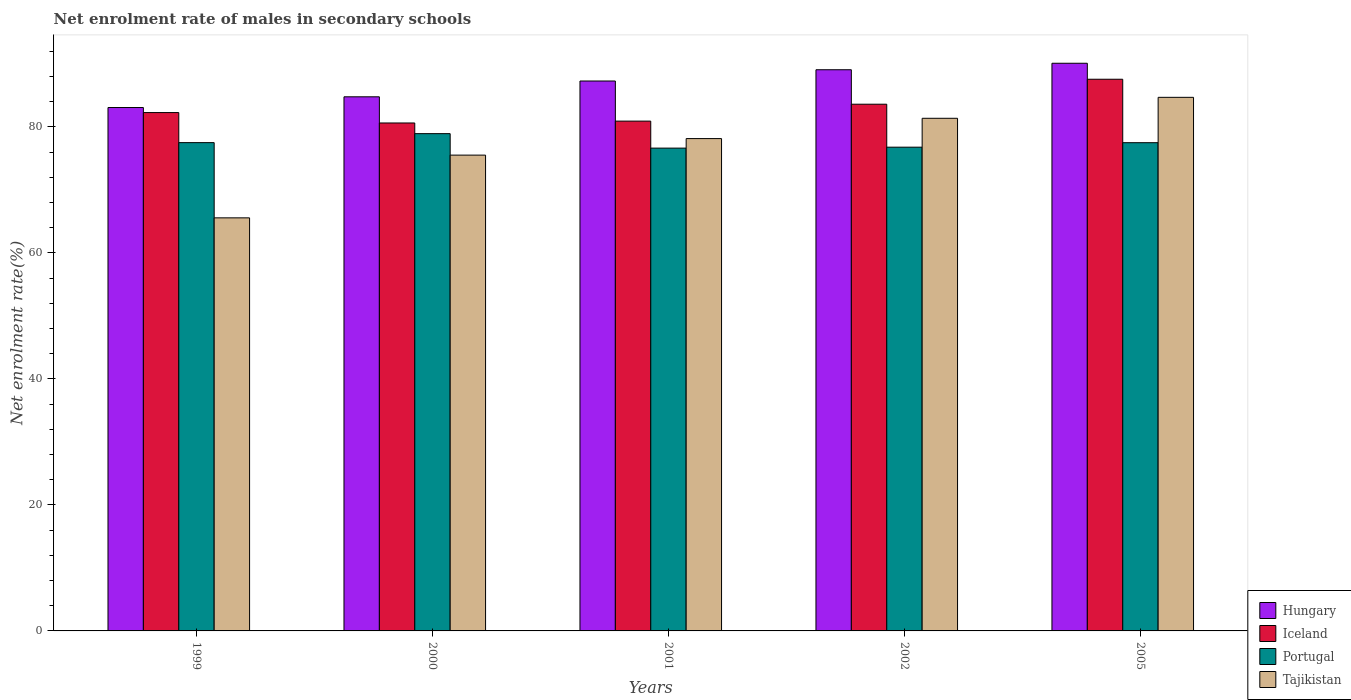How many different coloured bars are there?
Your answer should be compact. 4. How many bars are there on the 3rd tick from the left?
Your response must be concise. 4. What is the label of the 3rd group of bars from the left?
Keep it short and to the point. 2001. What is the net enrolment rate of males in secondary schools in Tajikistan in 2002?
Your answer should be compact. 81.36. Across all years, what is the maximum net enrolment rate of males in secondary schools in Iceland?
Give a very brief answer. 87.55. Across all years, what is the minimum net enrolment rate of males in secondary schools in Iceland?
Ensure brevity in your answer.  80.61. In which year was the net enrolment rate of males in secondary schools in Portugal maximum?
Give a very brief answer. 2000. In which year was the net enrolment rate of males in secondary schools in Iceland minimum?
Keep it short and to the point. 2000. What is the total net enrolment rate of males in secondary schools in Iceland in the graph?
Your response must be concise. 414.92. What is the difference between the net enrolment rate of males in secondary schools in Portugal in 2000 and that in 2002?
Ensure brevity in your answer.  2.15. What is the difference between the net enrolment rate of males in secondary schools in Tajikistan in 2000 and the net enrolment rate of males in secondary schools in Hungary in 1999?
Keep it short and to the point. -7.55. What is the average net enrolment rate of males in secondary schools in Tajikistan per year?
Your answer should be very brief. 77.05. In the year 2005, what is the difference between the net enrolment rate of males in secondary schools in Hungary and net enrolment rate of males in secondary schools in Portugal?
Your answer should be compact. 12.61. What is the ratio of the net enrolment rate of males in secondary schools in Tajikistan in 1999 to that in 2000?
Give a very brief answer. 0.87. Is the difference between the net enrolment rate of males in secondary schools in Hungary in 1999 and 2002 greater than the difference between the net enrolment rate of males in secondary schools in Portugal in 1999 and 2002?
Make the answer very short. No. What is the difference between the highest and the second highest net enrolment rate of males in secondary schools in Hungary?
Offer a very short reply. 1.03. What is the difference between the highest and the lowest net enrolment rate of males in secondary schools in Tajikistan?
Ensure brevity in your answer.  19.13. In how many years, is the net enrolment rate of males in secondary schools in Hungary greater than the average net enrolment rate of males in secondary schools in Hungary taken over all years?
Your response must be concise. 3. What does the 1st bar from the left in 2005 represents?
Make the answer very short. Hungary. How many bars are there?
Give a very brief answer. 20. What is the difference between two consecutive major ticks on the Y-axis?
Provide a short and direct response. 20. Are the values on the major ticks of Y-axis written in scientific E-notation?
Your answer should be very brief. No. Does the graph contain any zero values?
Your answer should be compact. No. Does the graph contain grids?
Ensure brevity in your answer.  No. What is the title of the graph?
Your answer should be compact. Net enrolment rate of males in secondary schools. Does "Mali" appear as one of the legend labels in the graph?
Provide a short and direct response. No. What is the label or title of the Y-axis?
Ensure brevity in your answer.  Net enrolment rate(%). What is the Net enrolment rate(%) of Hungary in 1999?
Your answer should be very brief. 83.06. What is the Net enrolment rate(%) of Iceland in 1999?
Give a very brief answer. 82.26. What is the Net enrolment rate(%) of Portugal in 1999?
Offer a very short reply. 77.49. What is the Net enrolment rate(%) in Tajikistan in 1999?
Give a very brief answer. 65.55. What is the Net enrolment rate(%) of Hungary in 2000?
Your answer should be compact. 84.76. What is the Net enrolment rate(%) in Iceland in 2000?
Ensure brevity in your answer.  80.61. What is the Net enrolment rate(%) of Portugal in 2000?
Give a very brief answer. 78.92. What is the Net enrolment rate(%) of Tajikistan in 2000?
Your answer should be very brief. 75.51. What is the Net enrolment rate(%) of Hungary in 2001?
Make the answer very short. 87.27. What is the Net enrolment rate(%) of Iceland in 2001?
Your response must be concise. 80.91. What is the Net enrolment rate(%) of Portugal in 2001?
Your answer should be very brief. 76.62. What is the Net enrolment rate(%) of Tajikistan in 2001?
Provide a succinct answer. 78.13. What is the Net enrolment rate(%) of Hungary in 2002?
Offer a very short reply. 89.06. What is the Net enrolment rate(%) in Iceland in 2002?
Make the answer very short. 83.59. What is the Net enrolment rate(%) of Portugal in 2002?
Give a very brief answer. 76.77. What is the Net enrolment rate(%) of Tajikistan in 2002?
Offer a very short reply. 81.36. What is the Net enrolment rate(%) in Hungary in 2005?
Offer a terse response. 90.09. What is the Net enrolment rate(%) in Iceland in 2005?
Your response must be concise. 87.55. What is the Net enrolment rate(%) in Portugal in 2005?
Your answer should be compact. 77.48. What is the Net enrolment rate(%) in Tajikistan in 2005?
Your answer should be very brief. 84.68. Across all years, what is the maximum Net enrolment rate(%) of Hungary?
Your answer should be very brief. 90.09. Across all years, what is the maximum Net enrolment rate(%) of Iceland?
Provide a succinct answer. 87.55. Across all years, what is the maximum Net enrolment rate(%) in Portugal?
Keep it short and to the point. 78.92. Across all years, what is the maximum Net enrolment rate(%) in Tajikistan?
Provide a short and direct response. 84.68. Across all years, what is the minimum Net enrolment rate(%) of Hungary?
Offer a terse response. 83.06. Across all years, what is the minimum Net enrolment rate(%) of Iceland?
Make the answer very short. 80.61. Across all years, what is the minimum Net enrolment rate(%) in Portugal?
Your answer should be compact. 76.62. Across all years, what is the minimum Net enrolment rate(%) of Tajikistan?
Your answer should be very brief. 65.55. What is the total Net enrolment rate(%) of Hungary in the graph?
Provide a short and direct response. 434.25. What is the total Net enrolment rate(%) of Iceland in the graph?
Give a very brief answer. 414.92. What is the total Net enrolment rate(%) of Portugal in the graph?
Your answer should be very brief. 387.29. What is the total Net enrolment rate(%) in Tajikistan in the graph?
Your answer should be very brief. 385.23. What is the difference between the Net enrolment rate(%) in Hungary in 1999 and that in 2000?
Provide a succinct answer. -1.7. What is the difference between the Net enrolment rate(%) of Iceland in 1999 and that in 2000?
Keep it short and to the point. 1.65. What is the difference between the Net enrolment rate(%) of Portugal in 1999 and that in 2000?
Offer a very short reply. -1.43. What is the difference between the Net enrolment rate(%) of Tajikistan in 1999 and that in 2000?
Your answer should be compact. -9.96. What is the difference between the Net enrolment rate(%) in Hungary in 1999 and that in 2001?
Make the answer very short. -4.21. What is the difference between the Net enrolment rate(%) in Iceland in 1999 and that in 2001?
Your response must be concise. 1.36. What is the difference between the Net enrolment rate(%) of Portugal in 1999 and that in 2001?
Your answer should be compact. 0.87. What is the difference between the Net enrolment rate(%) in Tajikistan in 1999 and that in 2001?
Your response must be concise. -12.58. What is the difference between the Net enrolment rate(%) in Hungary in 1999 and that in 2002?
Keep it short and to the point. -6. What is the difference between the Net enrolment rate(%) of Iceland in 1999 and that in 2002?
Your answer should be very brief. -1.33. What is the difference between the Net enrolment rate(%) in Portugal in 1999 and that in 2002?
Your answer should be compact. 0.72. What is the difference between the Net enrolment rate(%) of Tajikistan in 1999 and that in 2002?
Keep it short and to the point. -15.8. What is the difference between the Net enrolment rate(%) in Hungary in 1999 and that in 2005?
Provide a short and direct response. -7.02. What is the difference between the Net enrolment rate(%) of Iceland in 1999 and that in 2005?
Provide a succinct answer. -5.29. What is the difference between the Net enrolment rate(%) in Portugal in 1999 and that in 2005?
Ensure brevity in your answer.  0.01. What is the difference between the Net enrolment rate(%) of Tajikistan in 1999 and that in 2005?
Keep it short and to the point. -19.13. What is the difference between the Net enrolment rate(%) of Hungary in 2000 and that in 2001?
Provide a short and direct response. -2.51. What is the difference between the Net enrolment rate(%) in Iceland in 2000 and that in 2001?
Your response must be concise. -0.29. What is the difference between the Net enrolment rate(%) of Portugal in 2000 and that in 2001?
Ensure brevity in your answer.  2.3. What is the difference between the Net enrolment rate(%) in Tajikistan in 2000 and that in 2001?
Provide a succinct answer. -2.63. What is the difference between the Net enrolment rate(%) in Hungary in 2000 and that in 2002?
Keep it short and to the point. -4.3. What is the difference between the Net enrolment rate(%) of Iceland in 2000 and that in 2002?
Your response must be concise. -2.98. What is the difference between the Net enrolment rate(%) in Portugal in 2000 and that in 2002?
Provide a succinct answer. 2.15. What is the difference between the Net enrolment rate(%) in Tajikistan in 2000 and that in 2002?
Your answer should be compact. -5.85. What is the difference between the Net enrolment rate(%) in Hungary in 2000 and that in 2005?
Provide a succinct answer. -5.32. What is the difference between the Net enrolment rate(%) of Iceland in 2000 and that in 2005?
Offer a terse response. -6.94. What is the difference between the Net enrolment rate(%) of Portugal in 2000 and that in 2005?
Keep it short and to the point. 1.44. What is the difference between the Net enrolment rate(%) in Tajikistan in 2000 and that in 2005?
Make the answer very short. -9.17. What is the difference between the Net enrolment rate(%) in Hungary in 2001 and that in 2002?
Provide a succinct answer. -1.79. What is the difference between the Net enrolment rate(%) of Iceland in 2001 and that in 2002?
Provide a succinct answer. -2.68. What is the difference between the Net enrolment rate(%) in Portugal in 2001 and that in 2002?
Ensure brevity in your answer.  -0.15. What is the difference between the Net enrolment rate(%) of Tajikistan in 2001 and that in 2002?
Give a very brief answer. -3.22. What is the difference between the Net enrolment rate(%) in Hungary in 2001 and that in 2005?
Keep it short and to the point. -2.82. What is the difference between the Net enrolment rate(%) of Iceland in 2001 and that in 2005?
Your answer should be very brief. -6.65. What is the difference between the Net enrolment rate(%) of Portugal in 2001 and that in 2005?
Provide a succinct answer. -0.86. What is the difference between the Net enrolment rate(%) of Tajikistan in 2001 and that in 2005?
Ensure brevity in your answer.  -6.55. What is the difference between the Net enrolment rate(%) in Hungary in 2002 and that in 2005?
Your answer should be compact. -1.03. What is the difference between the Net enrolment rate(%) of Iceland in 2002 and that in 2005?
Offer a terse response. -3.96. What is the difference between the Net enrolment rate(%) of Portugal in 2002 and that in 2005?
Provide a short and direct response. -0.71. What is the difference between the Net enrolment rate(%) of Tajikistan in 2002 and that in 2005?
Your answer should be very brief. -3.32. What is the difference between the Net enrolment rate(%) of Hungary in 1999 and the Net enrolment rate(%) of Iceland in 2000?
Provide a succinct answer. 2.45. What is the difference between the Net enrolment rate(%) in Hungary in 1999 and the Net enrolment rate(%) in Portugal in 2000?
Your answer should be compact. 4.15. What is the difference between the Net enrolment rate(%) of Hungary in 1999 and the Net enrolment rate(%) of Tajikistan in 2000?
Offer a terse response. 7.55. What is the difference between the Net enrolment rate(%) in Iceland in 1999 and the Net enrolment rate(%) in Portugal in 2000?
Ensure brevity in your answer.  3.34. What is the difference between the Net enrolment rate(%) in Iceland in 1999 and the Net enrolment rate(%) in Tajikistan in 2000?
Provide a succinct answer. 6.75. What is the difference between the Net enrolment rate(%) in Portugal in 1999 and the Net enrolment rate(%) in Tajikistan in 2000?
Give a very brief answer. 1.98. What is the difference between the Net enrolment rate(%) in Hungary in 1999 and the Net enrolment rate(%) in Iceland in 2001?
Give a very brief answer. 2.16. What is the difference between the Net enrolment rate(%) of Hungary in 1999 and the Net enrolment rate(%) of Portugal in 2001?
Offer a very short reply. 6.44. What is the difference between the Net enrolment rate(%) in Hungary in 1999 and the Net enrolment rate(%) in Tajikistan in 2001?
Your response must be concise. 4.93. What is the difference between the Net enrolment rate(%) in Iceland in 1999 and the Net enrolment rate(%) in Portugal in 2001?
Give a very brief answer. 5.64. What is the difference between the Net enrolment rate(%) in Iceland in 1999 and the Net enrolment rate(%) in Tajikistan in 2001?
Make the answer very short. 4.13. What is the difference between the Net enrolment rate(%) in Portugal in 1999 and the Net enrolment rate(%) in Tajikistan in 2001?
Make the answer very short. -0.64. What is the difference between the Net enrolment rate(%) in Hungary in 1999 and the Net enrolment rate(%) in Iceland in 2002?
Your answer should be compact. -0.53. What is the difference between the Net enrolment rate(%) in Hungary in 1999 and the Net enrolment rate(%) in Portugal in 2002?
Offer a very short reply. 6.29. What is the difference between the Net enrolment rate(%) in Hungary in 1999 and the Net enrolment rate(%) in Tajikistan in 2002?
Provide a succinct answer. 1.71. What is the difference between the Net enrolment rate(%) of Iceland in 1999 and the Net enrolment rate(%) of Portugal in 2002?
Offer a terse response. 5.49. What is the difference between the Net enrolment rate(%) in Iceland in 1999 and the Net enrolment rate(%) in Tajikistan in 2002?
Your response must be concise. 0.91. What is the difference between the Net enrolment rate(%) of Portugal in 1999 and the Net enrolment rate(%) of Tajikistan in 2002?
Your answer should be compact. -3.86. What is the difference between the Net enrolment rate(%) in Hungary in 1999 and the Net enrolment rate(%) in Iceland in 2005?
Provide a succinct answer. -4.49. What is the difference between the Net enrolment rate(%) in Hungary in 1999 and the Net enrolment rate(%) in Portugal in 2005?
Give a very brief answer. 5.58. What is the difference between the Net enrolment rate(%) in Hungary in 1999 and the Net enrolment rate(%) in Tajikistan in 2005?
Provide a succinct answer. -1.62. What is the difference between the Net enrolment rate(%) in Iceland in 1999 and the Net enrolment rate(%) in Portugal in 2005?
Make the answer very short. 4.78. What is the difference between the Net enrolment rate(%) of Iceland in 1999 and the Net enrolment rate(%) of Tajikistan in 2005?
Your answer should be very brief. -2.42. What is the difference between the Net enrolment rate(%) of Portugal in 1999 and the Net enrolment rate(%) of Tajikistan in 2005?
Offer a terse response. -7.19. What is the difference between the Net enrolment rate(%) in Hungary in 2000 and the Net enrolment rate(%) in Iceland in 2001?
Provide a short and direct response. 3.86. What is the difference between the Net enrolment rate(%) of Hungary in 2000 and the Net enrolment rate(%) of Portugal in 2001?
Your answer should be very brief. 8.14. What is the difference between the Net enrolment rate(%) of Hungary in 2000 and the Net enrolment rate(%) of Tajikistan in 2001?
Give a very brief answer. 6.63. What is the difference between the Net enrolment rate(%) of Iceland in 2000 and the Net enrolment rate(%) of Portugal in 2001?
Your answer should be very brief. 3.99. What is the difference between the Net enrolment rate(%) in Iceland in 2000 and the Net enrolment rate(%) in Tajikistan in 2001?
Your response must be concise. 2.48. What is the difference between the Net enrolment rate(%) in Portugal in 2000 and the Net enrolment rate(%) in Tajikistan in 2001?
Make the answer very short. 0.78. What is the difference between the Net enrolment rate(%) of Hungary in 2000 and the Net enrolment rate(%) of Iceland in 2002?
Offer a terse response. 1.17. What is the difference between the Net enrolment rate(%) in Hungary in 2000 and the Net enrolment rate(%) in Portugal in 2002?
Provide a short and direct response. 7.99. What is the difference between the Net enrolment rate(%) in Hungary in 2000 and the Net enrolment rate(%) in Tajikistan in 2002?
Keep it short and to the point. 3.41. What is the difference between the Net enrolment rate(%) in Iceland in 2000 and the Net enrolment rate(%) in Portugal in 2002?
Keep it short and to the point. 3.84. What is the difference between the Net enrolment rate(%) in Iceland in 2000 and the Net enrolment rate(%) in Tajikistan in 2002?
Offer a terse response. -0.74. What is the difference between the Net enrolment rate(%) in Portugal in 2000 and the Net enrolment rate(%) in Tajikistan in 2002?
Make the answer very short. -2.44. What is the difference between the Net enrolment rate(%) in Hungary in 2000 and the Net enrolment rate(%) in Iceland in 2005?
Offer a very short reply. -2.79. What is the difference between the Net enrolment rate(%) of Hungary in 2000 and the Net enrolment rate(%) of Portugal in 2005?
Provide a short and direct response. 7.28. What is the difference between the Net enrolment rate(%) in Hungary in 2000 and the Net enrolment rate(%) in Tajikistan in 2005?
Provide a short and direct response. 0.08. What is the difference between the Net enrolment rate(%) of Iceland in 2000 and the Net enrolment rate(%) of Portugal in 2005?
Your answer should be compact. 3.13. What is the difference between the Net enrolment rate(%) in Iceland in 2000 and the Net enrolment rate(%) in Tajikistan in 2005?
Your answer should be compact. -4.07. What is the difference between the Net enrolment rate(%) in Portugal in 2000 and the Net enrolment rate(%) in Tajikistan in 2005?
Offer a terse response. -5.76. What is the difference between the Net enrolment rate(%) in Hungary in 2001 and the Net enrolment rate(%) in Iceland in 2002?
Your answer should be compact. 3.68. What is the difference between the Net enrolment rate(%) of Hungary in 2001 and the Net enrolment rate(%) of Portugal in 2002?
Give a very brief answer. 10.5. What is the difference between the Net enrolment rate(%) of Hungary in 2001 and the Net enrolment rate(%) of Tajikistan in 2002?
Your answer should be compact. 5.92. What is the difference between the Net enrolment rate(%) of Iceland in 2001 and the Net enrolment rate(%) of Portugal in 2002?
Your answer should be compact. 4.13. What is the difference between the Net enrolment rate(%) in Iceland in 2001 and the Net enrolment rate(%) in Tajikistan in 2002?
Offer a terse response. -0.45. What is the difference between the Net enrolment rate(%) in Portugal in 2001 and the Net enrolment rate(%) in Tajikistan in 2002?
Your response must be concise. -4.73. What is the difference between the Net enrolment rate(%) in Hungary in 2001 and the Net enrolment rate(%) in Iceland in 2005?
Offer a terse response. -0.28. What is the difference between the Net enrolment rate(%) of Hungary in 2001 and the Net enrolment rate(%) of Portugal in 2005?
Keep it short and to the point. 9.79. What is the difference between the Net enrolment rate(%) of Hungary in 2001 and the Net enrolment rate(%) of Tajikistan in 2005?
Offer a very short reply. 2.59. What is the difference between the Net enrolment rate(%) of Iceland in 2001 and the Net enrolment rate(%) of Portugal in 2005?
Offer a terse response. 3.42. What is the difference between the Net enrolment rate(%) of Iceland in 2001 and the Net enrolment rate(%) of Tajikistan in 2005?
Give a very brief answer. -3.77. What is the difference between the Net enrolment rate(%) in Portugal in 2001 and the Net enrolment rate(%) in Tajikistan in 2005?
Provide a succinct answer. -8.06. What is the difference between the Net enrolment rate(%) in Hungary in 2002 and the Net enrolment rate(%) in Iceland in 2005?
Your answer should be very brief. 1.51. What is the difference between the Net enrolment rate(%) of Hungary in 2002 and the Net enrolment rate(%) of Portugal in 2005?
Your answer should be very brief. 11.58. What is the difference between the Net enrolment rate(%) in Hungary in 2002 and the Net enrolment rate(%) in Tajikistan in 2005?
Keep it short and to the point. 4.38. What is the difference between the Net enrolment rate(%) of Iceland in 2002 and the Net enrolment rate(%) of Portugal in 2005?
Ensure brevity in your answer.  6.11. What is the difference between the Net enrolment rate(%) of Iceland in 2002 and the Net enrolment rate(%) of Tajikistan in 2005?
Offer a terse response. -1.09. What is the difference between the Net enrolment rate(%) in Portugal in 2002 and the Net enrolment rate(%) in Tajikistan in 2005?
Make the answer very short. -7.91. What is the average Net enrolment rate(%) in Hungary per year?
Ensure brevity in your answer.  86.85. What is the average Net enrolment rate(%) of Iceland per year?
Your answer should be very brief. 82.98. What is the average Net enrolment rate(%) in Portugal per year?
Give a very brief answer. 77.46. What is the average Net enrolment rate(%) in Tajikistan per year?
Your answer should be compact. 77.05. In the year 1999, what is the difference between the Net enrolment rate(%) in Hungary and Net enrolment rate(%) in Iceland?
Make the answer very short. 0.8. In the year 1999, what is the difference between the Net enrolment rate(%) of Hungary and Net enrolment rate(%) of Portugal?
Give a very brief answer. 5.57. In the year 1999, what is the difference between the Net enrolment rate(%) in Hungary and Net enrolment rate(%) in Tajikistan?
Your response must be concise. 17.51. In the year 1999, what is the difference between the Net enrolment rate(%) in Iceland and Net enrolment rate(%) in Portugal?
Offer a terse response. 4.77. In the year 1999, what is the difference between the Net enrolment rate(%) in Iceland and Net enrolment rate(%) in Tajikistan?
Make the answer very short. 16.71. In the year 1999, what is the difference between the Net enrolment rate(%) in Portugal and Net enrolment rate(%) in Tajikistan?
Offer a terse response. 11.94. In the year 2000, what is the difference between the Net enrolment rate(%) in Hungary and Net enrolment rate(%) in Iceland?
Give a very brief answer. 4.15. In the year 2000, what is the difference between the Net enrolment rate(%) of Hungary and Net enrolment rate(%) of Portugal?
Your answer should be very brief. 5.85. In the year 2000, what is the difference between the Net enrolment rate(%) of Hungary and Net enrolment rate(%) of Tajikistan?
Give a very brief answer. 9.25. In the year 2000, what is the difference between the Net enrolment rate(%) in Iceland and Net enrolment rate(%) in Portugal?
Your response must be concise. 1.69. In the year 2000, what is the difference between the Net enrolment rate(%) in Iceland and Net enrolment rate(%) in Tajikistan?
Offer a terse response. 5.1. In the year 2000, what is the difference between the Net enrolment rate(%) in Portugal and Net enrolment rate(%) in Tajikistan?
Make the answer very short. 3.41. In the year 2001, what is the difference between the Net enrolment rate(%) of Hungary and Net enrolment rate(%) of Iceland?
Ensure brevity in your answer.  6.37. In the year 2001, what is the difference between the Net enrolment rate(%) of Hungary and Net enrolment rate(%) of Portugal?
Your answer should be very brief. 10.65. In the year 2001, what is the difference between the Net enrolment rate(%) of Hungary and Net enrolment rate(%) of Tajikistan?
Offer a terse response. 9.14. In the year 2001, what is the difference between the Net enrolment rate(%) of Iceland and Net enrolment rate(%) of Portugal?
Offer a very short reply. 4.28. In the year 2001, what is the difference between the Net enrolment rate(%) in Iceland and Net enrolment rate(%) in Tajikistan?
Ensure brevity in your answer.  2.77. In the year 2001, what is the difference between the Net enrolment rate(%) of Portugal and Net enrolment rate(%) of Tajikistan?
Offer a terse response. -1.51. In the year 2002, what is the difference between the Net enrolment rate(%) in Hungary and Net enrolment rate(%) in Iceland?
Your answer should be compact. 5.47. In the year 2002, what is the difference between the Net enrolment rate(%) of Hungary and Net enrolment rate(%) of Portugal?
Your answer should be very brief. 12.29. In the year 2002, what is the difference between the Net enrolment rate(%) in Hungary and Net enrolment rate(%) in Tajikistan?
Ensure brevity in your answer.  7.7. In the year 2002, what is the difference between the Net enrolment rate(%) of Iceland and Net enrolment rate(%) of Portugal?
Give a very brief answer. 6.82. In the year 2002, what is the difference between the Net enrolment rate(%) of Iceland and Net enrolment rate(%) of Tajikistan?
Give a very brief answer. 2.23. In the year 2002, what is the difference between the Net enrolment rate(%) of Portugal and Net enrolment rate(%) of Tajikistan?
Give a very brief answer. -4.58. In the year 2005, what is the difference between the Net enrolment rate(%) of Hungary and Net enrolment rate(%) of Iceland?
Provide a short and direct response. 2.54. In the year 2005, what is the difference between the Net enrolment rate(%) in Hungary and Net enrolment rate(%) in Portugal?
Your answer should be very brief. 12.61. In the year 2005, what is the difference between the Net enrolment rate(%) of Hungary and Net enrolment rate(%) of Tajikistan?
Provide a short and direct response. 5.41. In the year 2005, what is the difference between the Net enrolment rate(%) of Iceland and Net enrolment rate(%) of Portugal?
Keep it short and to the point. 10.07. In the year 2005, what is the difference between the Net enrolment rate(%) of Iceland and Net enrolment rate(%) of Tajikistan?
Your answer should be very brief. 2.87. In the year 2005, what is the difference between the Net enrolment rate(%) of Portugal and Net enrolment rate(%) of Tajikistan?
Your answer should be compact. -7.2. What is the ratio of the Net enrolment rate(%) of Hungary in 1999 to that in 2000?
Your answer should be compact. 0.98. What is the ratio of the Net enrolment rate(%) of Iceland in 1999 to that in 2000?
Ensure brevity in your answer.  1.02. What is the ratio of the Net enrolment rate(%) in Portugal in 1999 to that in 2000?
Offer a very short reply. 0.98. What is the ratio of the Net enrolment rate(%) of Tajikistan in 1999 to that in 2000?
Offer a very short reply. 0.87. What is the ratio of the Net enrolment rate(%) in Hungary in 1999 to that in 2001?
Your response must be concise. 0.95. What is the ratio of the Net enrolment rate(%) in Iceland in 1999 to that in 2001?
Provide a short and direct response. 1.02. What is the ratio of the Net enrolment rate(%) of Portugal in 1999 to that in 2001?
Offer a very short reply. 1.01. What is the ratio of the Net enrolment rate(%) in Tajikistan in 1999 to that in 2001?
Make the answer very short. 0.84. What is the ratio of the Net enrolment rate(%) in Hungary in 1999 to that in 2002?
Your response must be concise. 0.93. What is the ratio of the Net enrolment rate(%) of Iceland in 1999 to that in 2002?
Provide a succinct answer. 0.98. What is the ratio of the Net enrolment rate(%) of Portugal in 1999 to that in 2002?
Keep it short and to the point. 1.01. What is the ratio of the Net enrolment rate(%) in Tajikistan in 1999 to that in 2002?
Make the answer very short. 0.81. What is the ratio of the Net enrolment rate(%) of Hungary in 1999 to that in 2005?
Keep it short and to the point. 0.92. What is the ratio of the Net enrolment rate(%) of Iceland in 1999 to that in 2005?
Provide a succinct answer. 0.94. What is the ratio of the Net enrolment rate(%) in Tajikistan in 1999 to that in 2005?
Ensure brevity in your answer.  0.77. What is the ratio of the Net enrolment rate(%) in Hungary in 2000 to that in 2001?
Provide a short and direct response. 0.97. What is the ratio of the Net enrolment rate(%) of Tajikistan in 2000 to that in 2001?
Keep it short and to the point. 0.97. What is the ratio of the Net enrolment rate(%) of Hungary in 2000 to that in 2002?
Your answer should be very brief. 0.95. What is the ratio of the Net enrolment rate(%) in Iceland in 2000 to that in 2002?
Your answer should be very brief. 0.96. What is the ratio of the Net enrolment rate(%) of Portugal in 2000 to that in 2002?
Make the answer very short. 1.03. What is the ratio of the Net enrolment rate(%) of Tajikistan in 2000 to that in 2002?
Provide a succinct answer. 0.93. What is the ratio of the Net enrolment rate(%) in Hungary in 2000 to that in 2005?
Give a very brief answer. 0.94. What is the ratio of the Net enrolment rate(%) of Iceland in 2000 to that in 2005?
Offer a very short reply. 0.92. What is the ratio of the Net enrolment rate(%) in Portugal in 2000 to that in 2005?
Ensure brevity in your answer.  1.02. What is the ratio of the Net enrolment rate(%) in Tajikistan in 2000 to that in 2005?
Offer a terse response. 0.89. What is the ratio of the Net enrolment rate(%) in Hungary in 2001 to that in 2002?
Offer a very short reply. 0.98. What is the ratio of the Net enrolment rate(%) in Iceland in 2001 to that in 2002?
Offer a terse response. 0.97. What is the ratio of the Net enrolment rate(%) of Tajikistan in 2001 to that in 2002?
Your answer should be very brief. 0.96. What is the ratio of the Net enrolment rate(%) in Hungary in 2001 to that in 2005?
Ensure brevity in your answer.  0.97. What is the ratio of the Net enrolment rate(%) of Iceland in 2001 to that in 2005?
Your answer should be compact. 0.92. What is the ratio of the Net enrolment rate(%) in Portugal in 2001 to that in 2005?
Ensure brevity in your answer.  0.99. What is the ratio of the Net enrolment rate(%) of Tajikistan in 2001 to that in 2005?
Ensure brevity in your answer.  0.92. What is the ratio of the Net enrolment rate(%) of Hungary in 2002 to that in 2005?
Your answer should be very brief. 0.99. What is the ratio of the Net enrolment rate(%) of Iceland in 2002 to that in 2005?
Give a very brief answer. 0.95. What is the ratio of the Net enrolment rate(%) in Portugal in 2002 to that in 2005?
Provide a succinct answer. 0.99. What is the ratio of the Net enrolment rate(%) of Tajikistan in 2002 to that in 2005?
Your answer should be compact. 0.96. What is the difference between the highest and the second highest Net enrolment rate(%) of Hungary?
Make the answer very short. 1.03. What is the difference between the highest and the second highest Net enrolment rate(%) of Iceland?
Your response must be concise. 3.96. What is the difference between the highest and the second highest Net enrolment rate(%) of Portugal?
Provide a short and direct response. 1.43. What is the difference between the highest and the second highest Net enrolment rate(%) in Tajikistan?
Provide a succinct answer. 3.32. What is the difference between the highest and the lowest Net enrolment rate(%) in Hungary?
Give a very brief answer. 7.02. What is the difference between the highest and the lowest Net enrolment rate(%) in Iceland?
Offer a very short reply. 6.94. What is the difference between the highest and the lowest Net enrolment rate(%) of Portugal?
Provide a short and direct response. 2.3. What is the difference between the highest and the lowest Net enrolment rate(%) in Tajikistan?
Your answer should be compact. 19.13. 